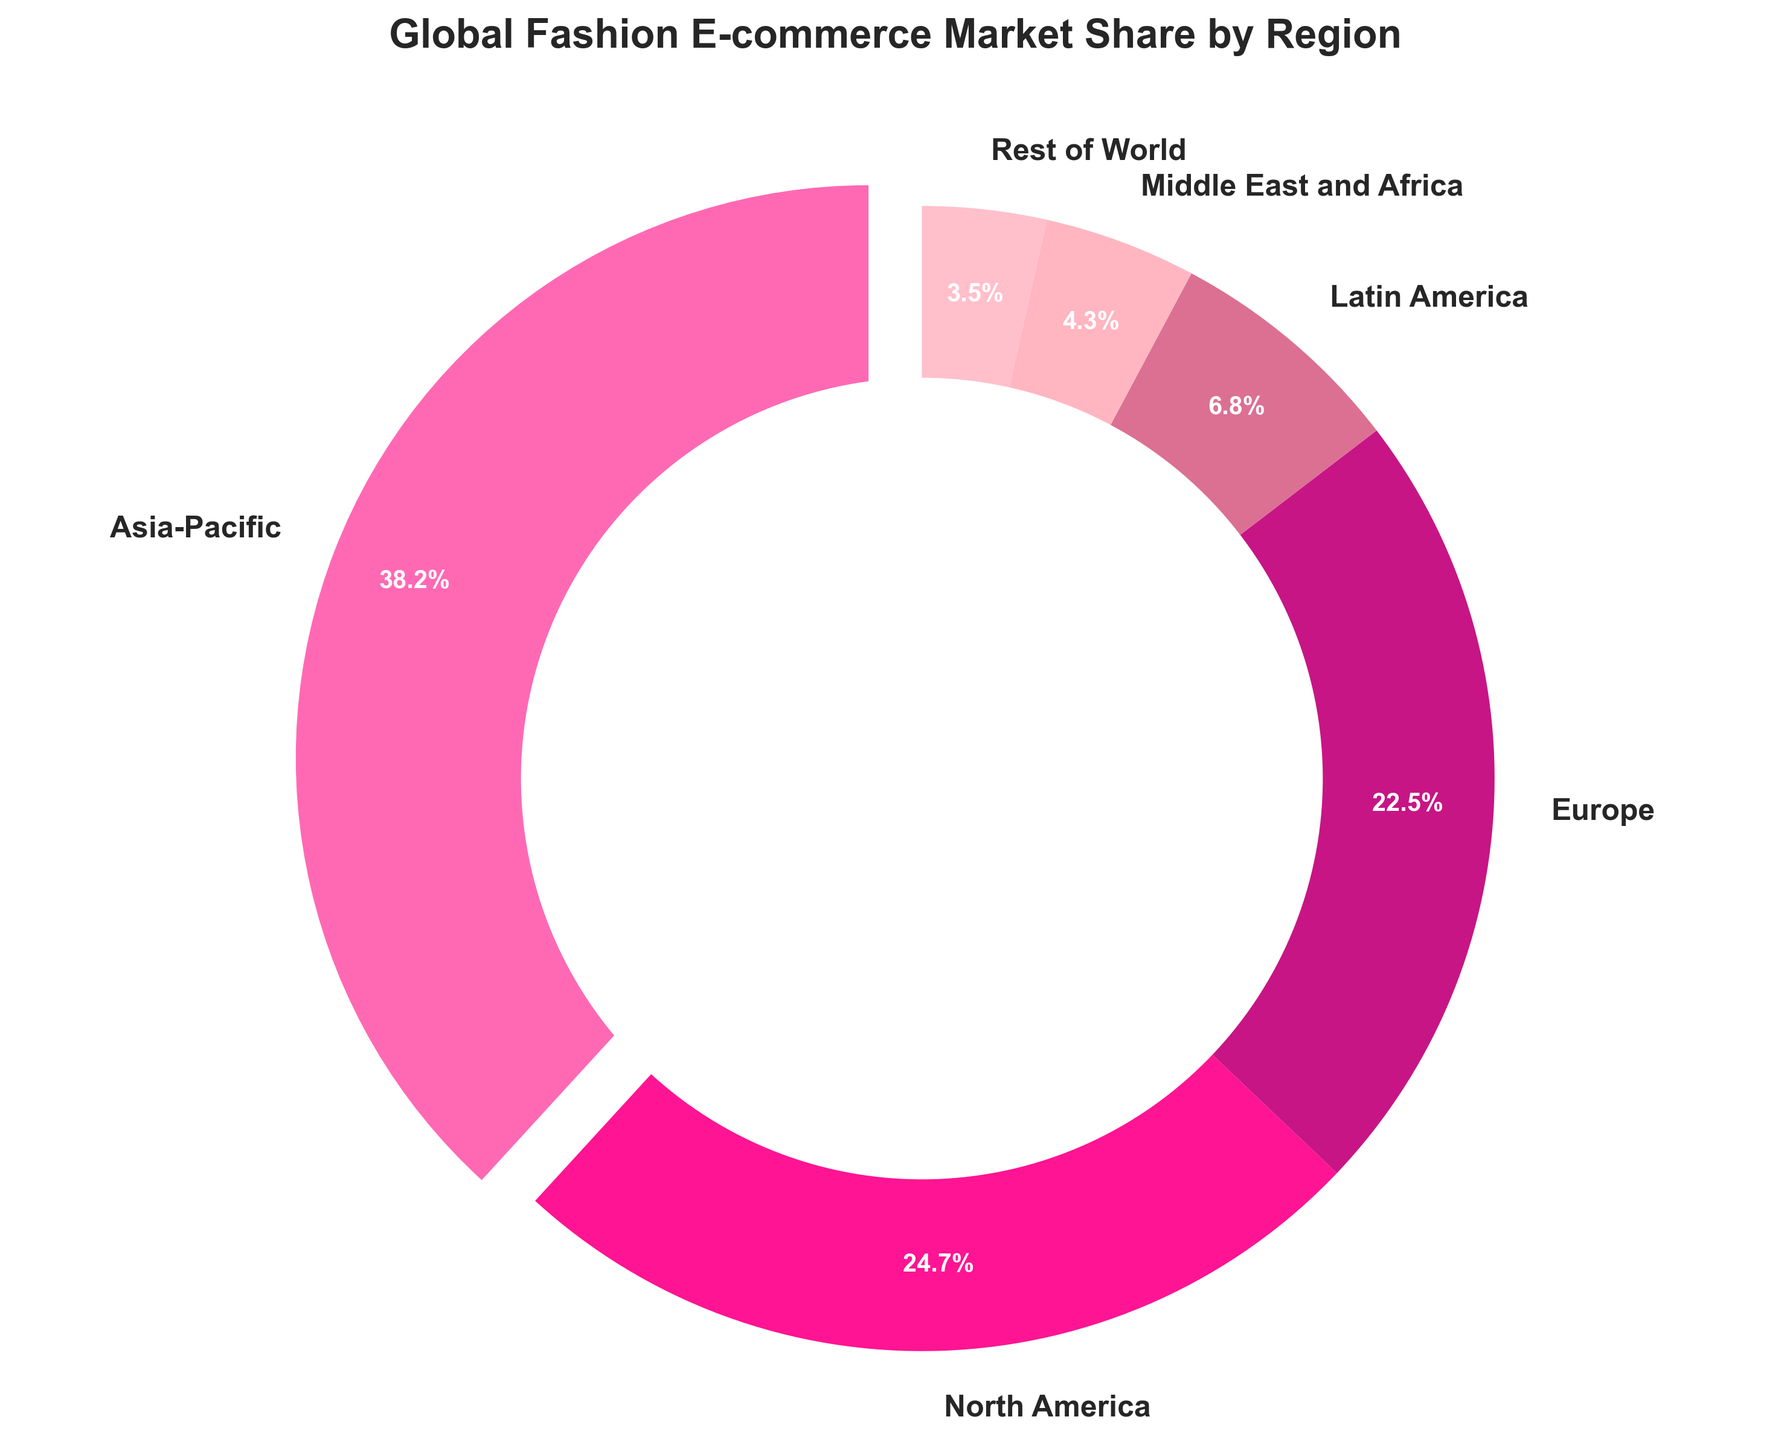What's the region with the highest market share in global fashion e-commerce? The figure segments are labeled with the regions and their respective market shares. The largest segment is for Asia-Pacific, which claims the highest percentage.
Answer: Asia-Pacific Which two regions have the smallest combined market share in global fashion e-commerce? By observing the segments and their labels, the two smallest shares are for "Middle East and Africa" (4.3%) and "Rest of World" (3.5%). Adding these values gives a combined share of 7.8%.
Answer: Middle East and Africa and Rest of World How much more market share does North America have compared to Europe? The figure shows that North America has 24.7% market share, while Europe has 22.5%. Subtracting the percentages (24.7 - 22.5) gives the difference.
Answer: 2.2% Which region's market share is closest to one-quarter of the total market? One quarter of 100% is 25%. Looking at the figure, North America has a market share of 24.7%, which is closest to 25%.
Answer: North America What is the total market share of regions other than Asia-Pacific? Asia-Pacific has a 38.2% market share. The other regions thus make up 100 - 38.2 = 61.8%.
Answer: 61.8% Which region represents about one-fifth of the global fashion e-commerce market? One fifth of 100% is 20%. Europe, with a 22.5% market share, is closest to one-fifth.
Answer: Europe If the Middle East and Africa market share increased by 1.7%, which two regions would then have equal market shares? The Middle East and Africa has 4.3% currently. Adding 1.7% gives it 6.0%. This matches the current share of Latin America, which is 6.8%.
Answer: Latin America and Middle East and Africa Which segment in the pie chart uses the pink color? The colors of the segments need to be identified. The segment colored in bright pink represents Latin America.
Answer: Latin America 